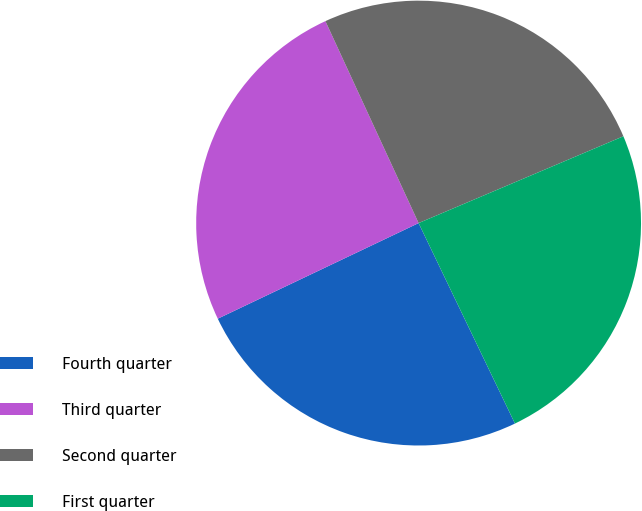<chart> <loc_0><loc_0><loc_500><loc_500><pie_chart><fcel>Fourth quarter<fcel>Third quarter<fcel>Second quarter<fcel>First quarter<nl><fcel>25.06%<fcel>25.19%<fcel>25.5%<fcel>24.25%<nl></chart> 